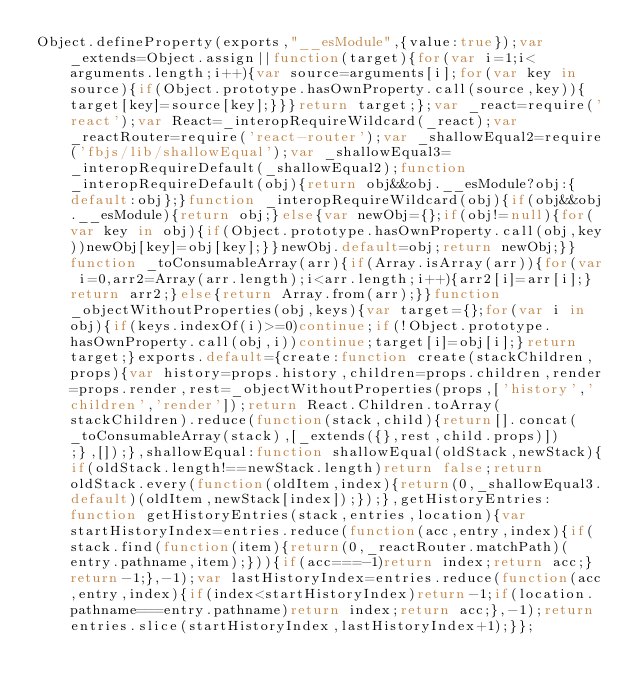<code> <loc_0><loc_0><loc_500><loc_500><_JavaScript_>Object.defineProperty(exports,"__esModule",{value:true});var _extends=Object.assign||function(target){for(var i=1;i<arguments.length;i++){var source=arguments[i];for(var key in source){if(Object.prototype.hasOwnProperty.call(source,key)){target[key]=source[key];}}}return target;};var _react=require('react');var React=_interopRequireWildcard(_react);var _reactRouter=require('react-router');var _shallowEqual2=require('fbjs/lib/shallowEqual');var _shallowEqual3=_interopRequireDefault(_shallowEqual2);function _interopRequireDefault(obj){return obj&&obj.__esModule?obj:{default:obj};}function _interopRequireWildcard(obj){if(obj&&obj.__esModule){return obj;}else{var newObj={};if(obj!=null){for(var key in obj){if(Object.prototype.hasOwnProperty.call(obj,key))newObj[key]=obj[key];}}newObj.default=obj;return newObj;}}function _toConsumableArray(arr){if(Array.isArray(arr)){for(var i=0,arr2=Array(arr.length);i<arr.length;i++){arr2[i]=arr[i];}return arr2;}else{return Array.from(arr);}}function _objectWithoutProperties(obj,keys){var target={};for(var i in obj){if(keys.indexOf(i)>=0)continue;if(!Object.prototype.hasOwnProperty.call(obj,i))continue;target[i]=obj[i];}return target;}exports.default={create:function create(stackChildren,props){var history=props.history,children=props.children,render=props.render,rest=_objectWithoutProperties(props,['history','children','render']);return React.Children.toArray(stackChildren).reduce(function(stack,child){return[].concat(_toConsumableArray(stack),[_extends({},rest,child.props)]);},[]);},shallowEqual:function shallowEqual(oldStack,newStack){if(oldStack.length!==newStack.length)return false;return oldStack.every(function(oldItem,index){return(0,_shallowEqual3.default)(oldItem,newStack[index]);});},getHistoryEntries:function getHistoryEntries(stack,entries,location){var startHistoryIndex=entries.reduce(function(acc,entry,index){if(stack.find(function(item){return(0,_reactRouter.matchPath)(entry.pathname,item);})){if(acc===-1)return index;return acc;}return-1;},-1);var lastHistoryIndex=entries.reduce(function(acc,entry,index){if(index<startHistoryIndex)return-1;if(location.pathname===entry.pathname)return index;return acc;},-1);return entries.slice(startHistoryIndex,lastHistoryIndex+1);}};</code> 